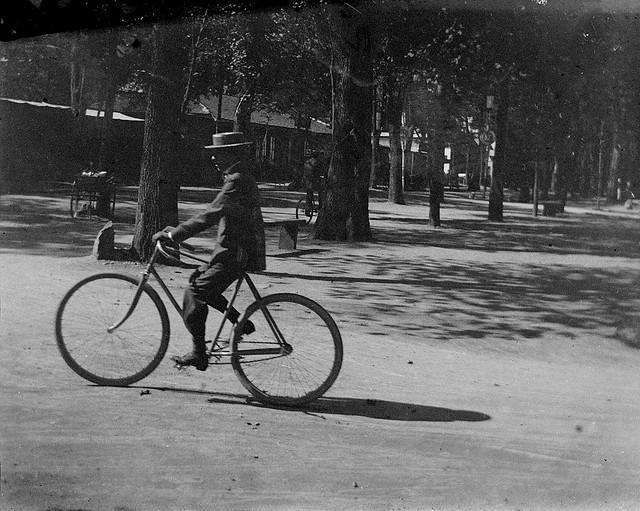How many bicycles are visible?
Give a very brief answer. 2. 